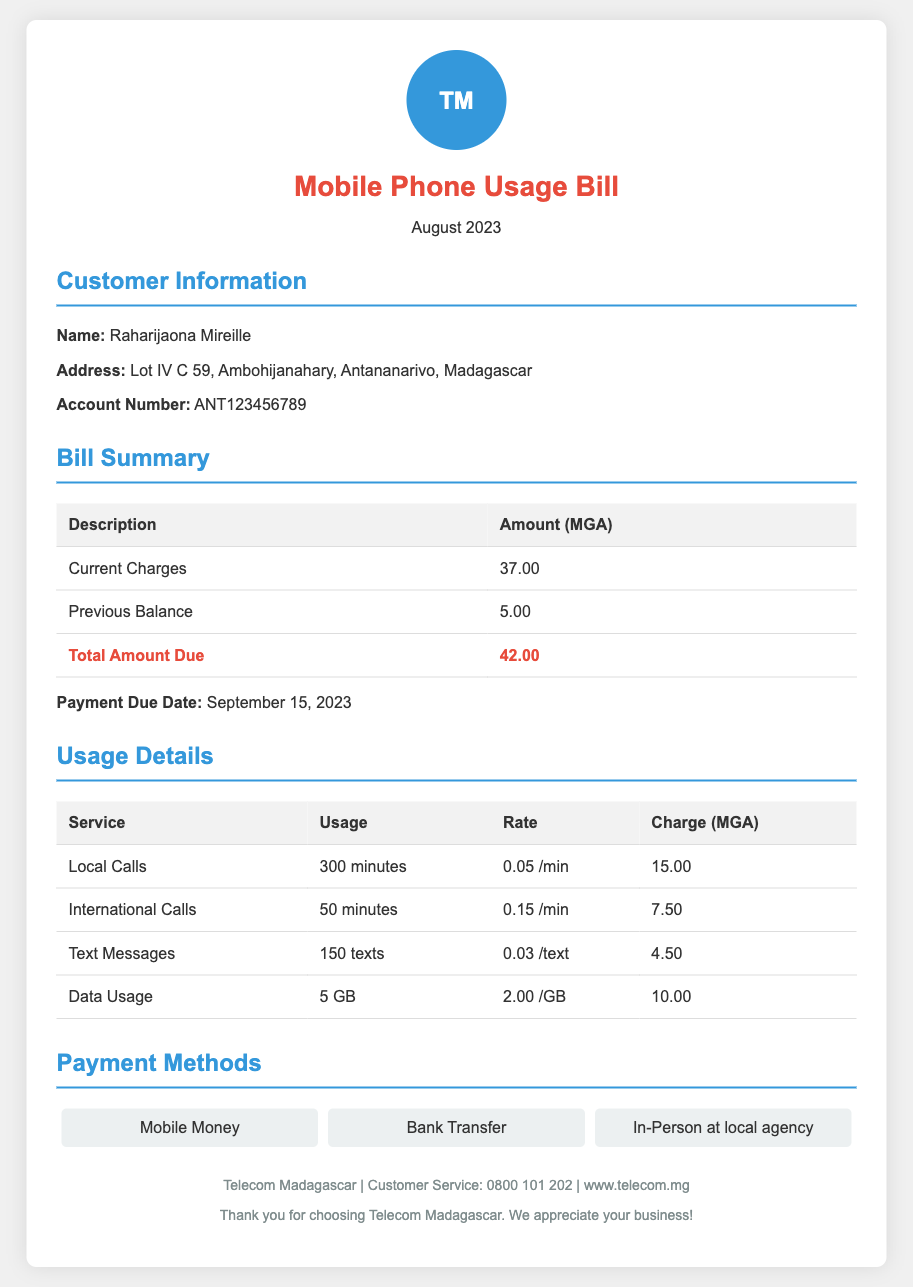What is the total amount due? The total amount due is provided in the bill summary section, calculating the current charges and previous balance.
Answer: 42.00 What is the payment due date? The payment due date is stated clearly in the bill summary section, indicating when the payment must be made.
Answer: September 15, 2023 Who is the bill addressed to? The bill includes customer information with the name of the account holder prominently featured.
Answer: Raharijaona Mireille How many minutes of local calls were made? The usage details section lists the amounts for different services, including local calls.
Answer: 300 minutes What is the charge for international calls? The specific charge for international calls is mentioned in the usage details table under charges.
Answer: 7.50 What is the charge for data usage? The usage details section specifies the rate for data and the total charge incurred for that month.
Answer: 10.00 How many text messages were sent? The number of text messages is provided in the usage details section.
Answer: 150 texts What payment methods are offered? The payment methods available are listed under the payment methods section of the bill.
Answer: Mobile Money, Bank Transfer, In-Person at local agency What is the total amount for local calls? The charge for local calls is specified in the usage details section, including the amount calculated for usage.
Answer: 15.00 